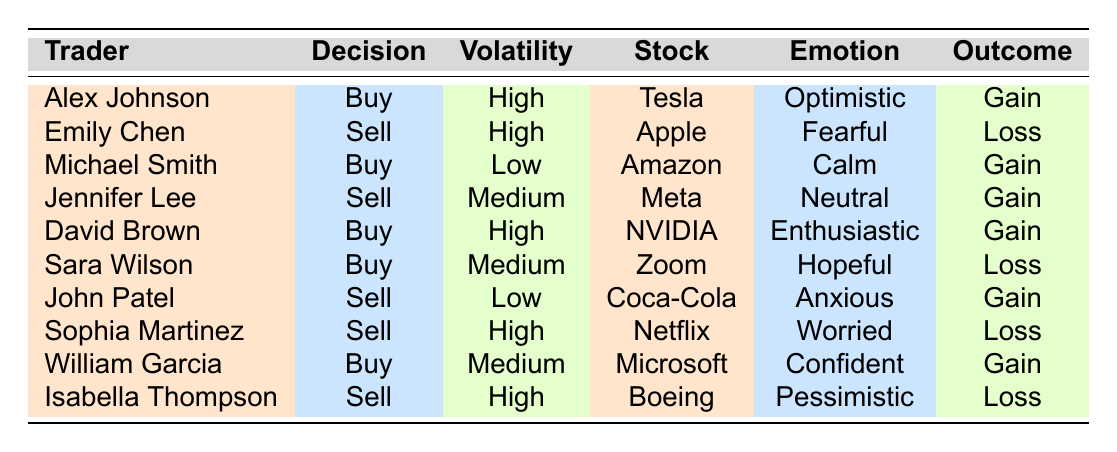What is the outcome for Alex Johnson's decision? Alex Johnson's decision is listed in the table under the 'outcome' column, which states that his outcome is a 'gain'.
Answer: Gain How many traders made buying decisions during high market volatility? The table shows two traders, Alex Johnson and David Brown, who both made buying decisions while the market was high in volatility.
Answer: 2 Which stock did Emily Chen sell? Looking at Emily Chen's row in the table, the stock she sold is 'Apple Inc.'.
Answer: Apple Inc Were there any traders who sold their stocks during low market volatility? The table indicates that John Patel sold his stock during low market volatility, which confirms that there was at least one trader who did so.
Answer: Yes What was the emotion of the trader who sold Netflix? The table indicates that Sophia Martinez sold Netflix, and her associated emotion is 'worried'.
Answer: Worried What is the average outcome of buying decisions made during medium market volatility? There are two buying decisions listed for medium volatility: Sara Wilson (loss) and William Garcia (gain). To find the average, we consider that one is a loss and one is a gain, thus resulting in a mix of outcomes, but since we're considering directional outcomes here, we can conclude they are not both gains. Therefore, the average outcome cannot be definitively quantified, but it's not purely positive.
Answer: Mixed outcomes Is there a trader who was optimistic and experienced a loss? The table lists Alex Johnson, who was optimistic with a gain, and Sara Wilson, who was hopeful but experienced a loss. Thus, there are no traders who were optimistic and got a loss.
Answer: No Which trader had the strongest emotion and what was their decision type? David Brown refers to his emotion as 'enthusiastic', and his decision type is 'buy'. Thus, he can be seen as having the strongest positive emotion linked to a buying action.
Answer: Buy How does Michael Smith's outcome compare to Sara Wilson's outcome? Michael Smith gained from buying Amazon while Sara Wilson lost from buying Zoom. In summary, Michael experienced a gain, while Sara had a loss.
Answer: Michael gained; Sara lost 